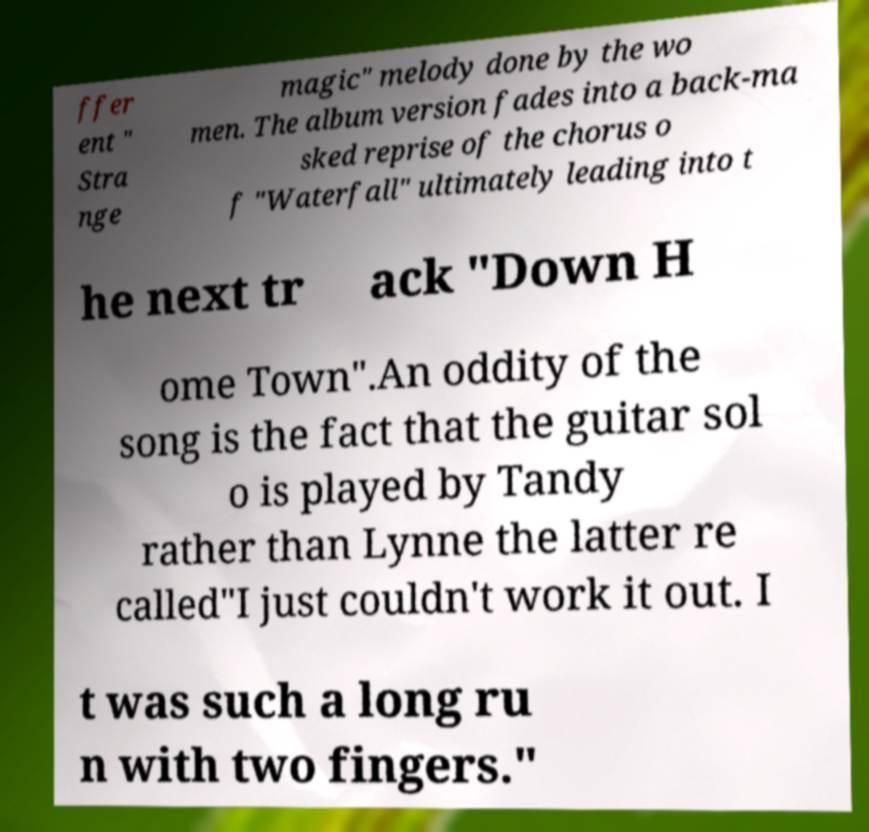Please read and relay the text visible in this image. What does it say? ffer ent " Stra nge magic" melody done by the wo men. The album version fades into a back-ma sked reprise of the chorus o f "Waterfall" ultimately leading into t he next tr ack "Down H ome Town".An oddity of the song is the fact that the guitar sol o is played by Tandy rather than Lynne the latter re called"I just couldn't work it out. I t was such a long ru n with two fingers." 